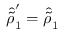Convert formula to latex. <formula><loc_0><loc_0><loc_500><loc_500>\hat { \tilde { \rho } } _ { 1 } ^ { \prime } = \hat { \tilde { \rho } } _ { 1 }</formula> 